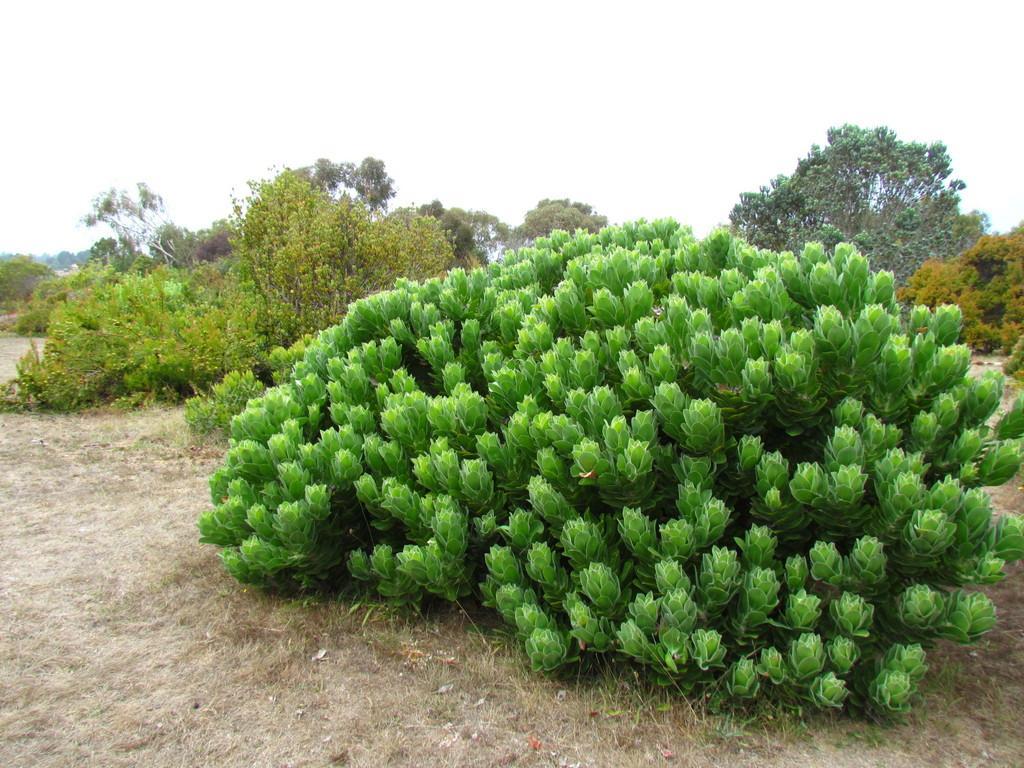Could you give a brief overview of what you see in this image? In the picture we can see a ground surface with plants and in the background also we can see full of plants and sky. 